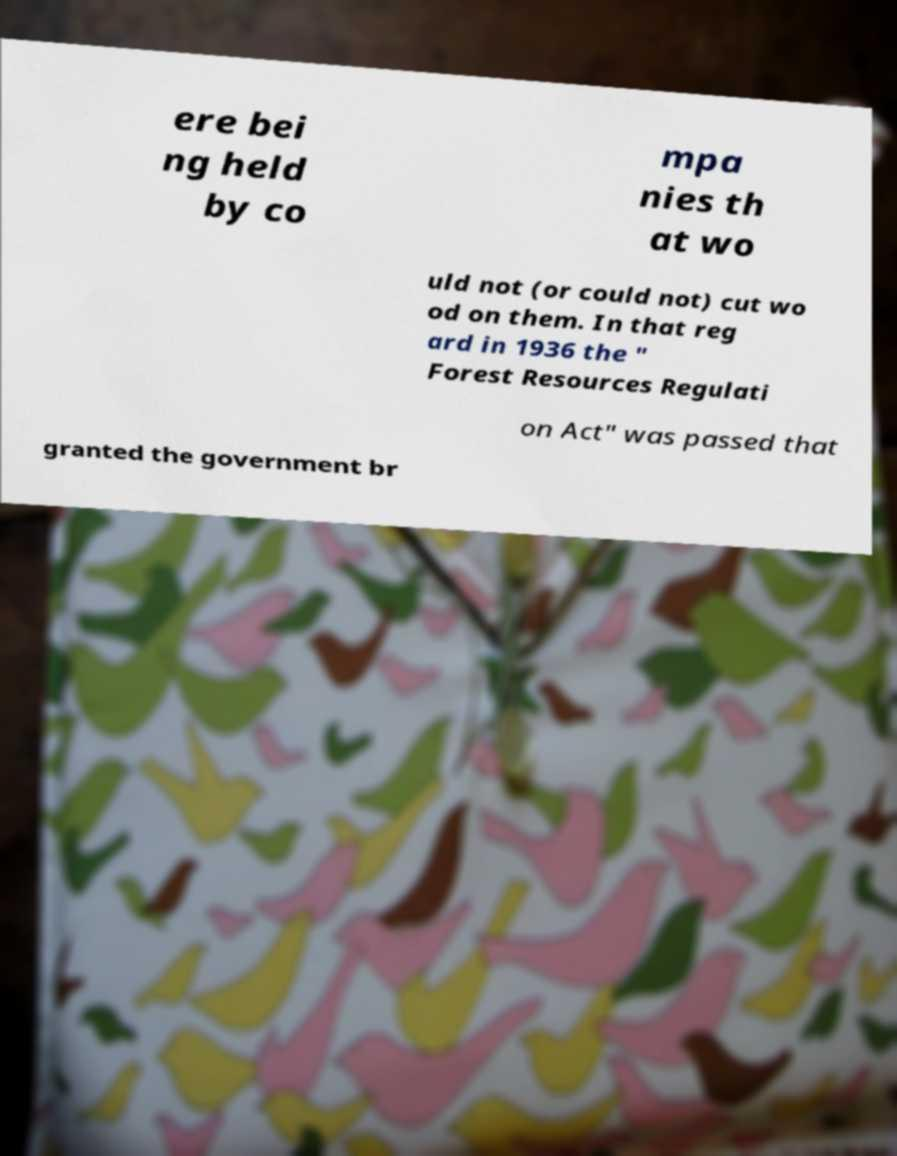Please read and relay the text visible in this image. What does it say? ere bei ng held by co mpa nies th at wo uld not (or could not) cut wo od on them. In that reg ard in 1936 the " Forest Resources Regulati on Act" was passed that granted the government br 